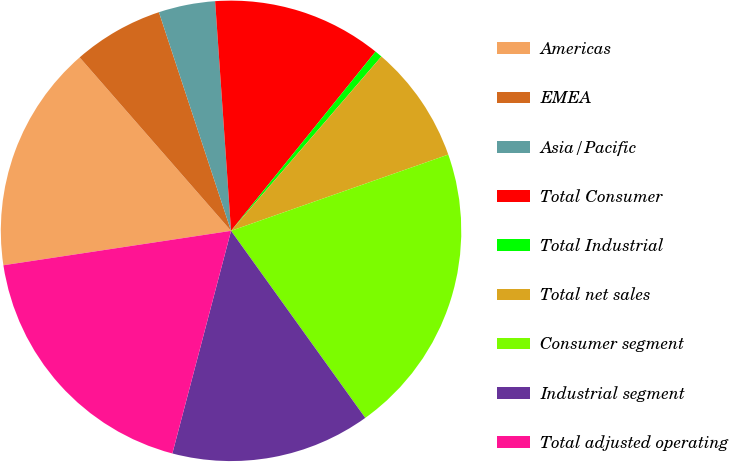<chart> <loc_0><loc_0><loc_500><loc_500><pie_chart><fcel>Americas<fcel>EMEA<fcel>Asia/Pacific<fcel>Total Consumer<fcel>Total Industrial<fcel>Total net sales<fcel>Consumer segment<fcel>Industrial segment<fcel>Total adjusted operating<nl><fcel>15.97%<fcel>6.35%<fcel>3.97%<fcel>11.9%<fcel>0.53%<fcel>8.3%<fcel>20.47%<fcel>14.01%<fcel>18.51%<nl></chart> 